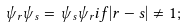Convert formula to latex. <formula><loc_0><loc_0><loc_500><loc_500>\psi _ { r } \psi _ { s } = \psi _ { s } \psi _ { r } i f | r - s | \neq 1 ;</formula> 